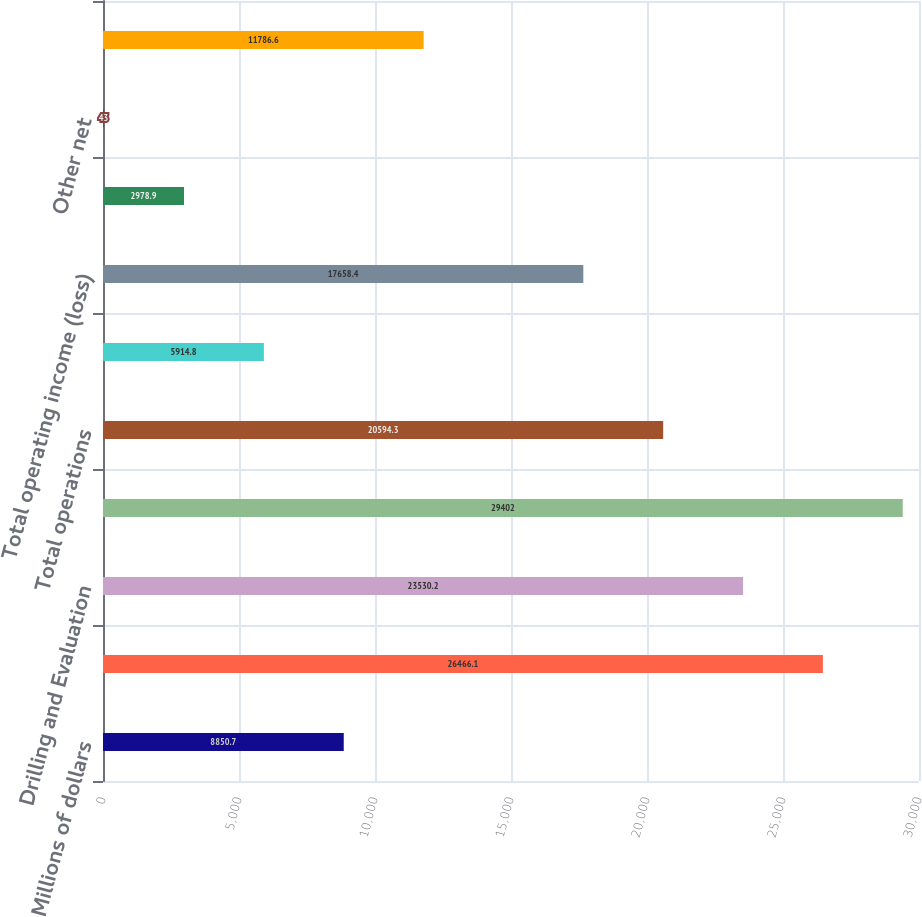Convert chart to OTSL. <chart><loc_0><loc_0><loc_500><loc_500><bar_chart><fcel>Millions of dollars<fcel>Completion and Production<fcel>Drilling and Evaluation<fcel>Total revenue<fcel>Total operations<fcel>Corporate and other<fcel>Total operating income (loss)<fcel>Interest expense net of<fcel>Other net<fcel>Income (loss) from continuing<nl><fcel>8850.7<fcel>26466.1<fcel>23530.2<fcel>29402<fcel>20594.3<fcel>5914.8<fcel>17658.4<fcel>2978.9<fcel>43<fcel>11786.6<nl></chart> 